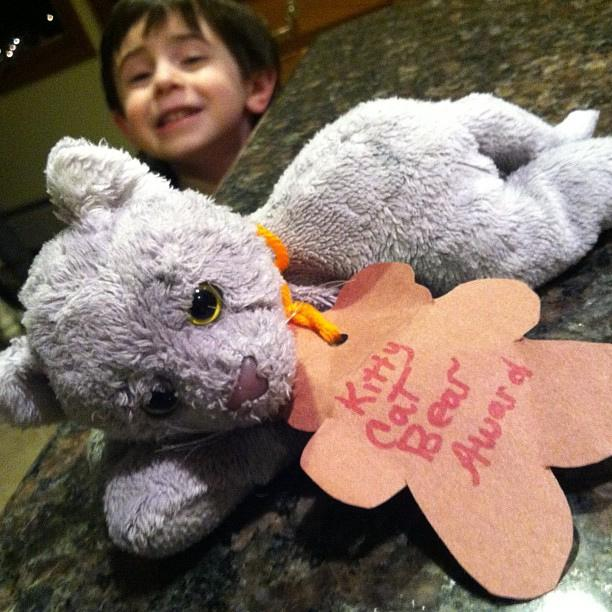What color is the twine wrapped around this little bear's neck? Please explain your reasoning. orange. The twine is not blue, red, or purple. 